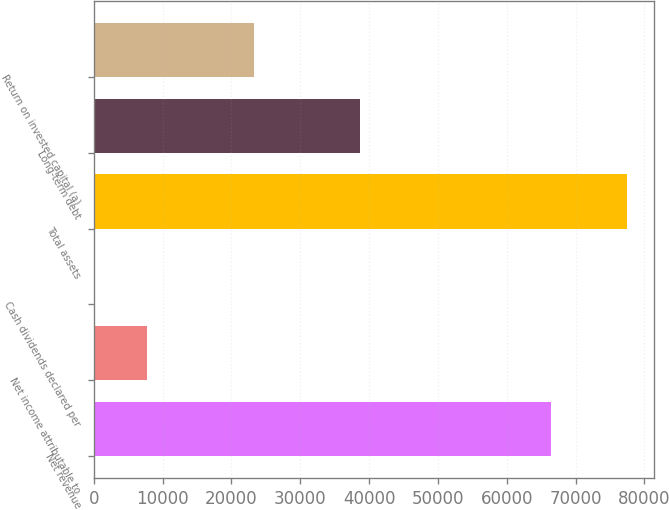Convert chart. <chart><loc_0><loc_0><loc_500><loc_500><bar_chart><fcel>Net revenue<fcel>Net income attributable to<fcel>Cash dividends declared per<fcel>Total assets<fcel>Long-term debt<fcel>Return on invested capital (a)<nl><fcel>66415<fcel>7749.82<fcel>2.24<fcel>77478<fcel>38740.1<fcel>23245<nl></chart> 